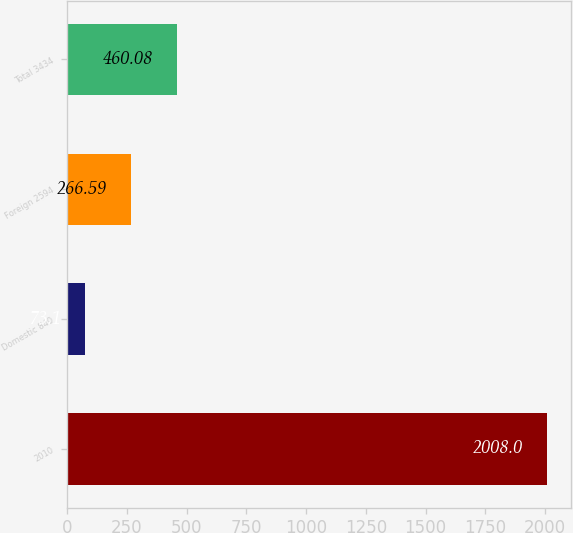Convert chart. <chart><loc_0><loc_0><loc_500><loc_500><bar_chart><fcel>2010<fcel>Domestic 840<fcel>Foreign 2594<fcel>Total 3434<nl><fcel>2008<fcel>73.1<fcel>266.59<fcel>460.08<nl></chart> 